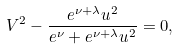Convert formula to latex. <formula><loc_0><loc_0><loc_500><loc_500>V ^ { 2 } - \frac { e ^ { \nu + \lambda } u ^ { 2 } } { e ^ { \nu } + e ^ { \nu + \lambda } u ^ { 2 } } = 0 ,</formula> 